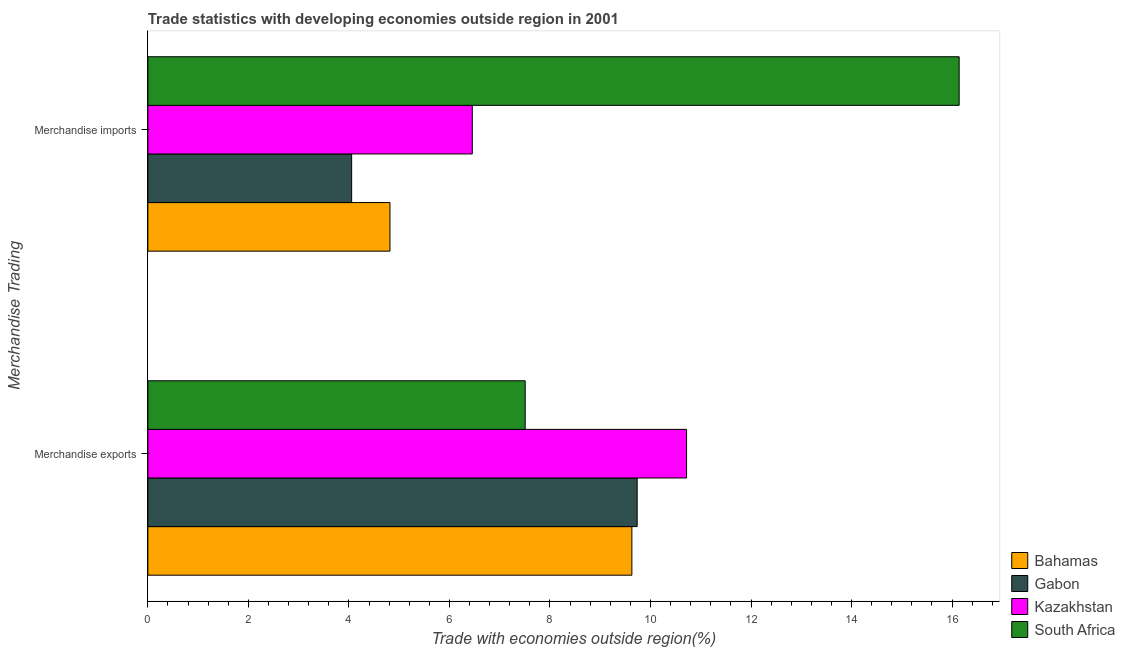How many different coloured bars are there?
Give a very brief answer. 4. How many groups of bars are there?
Ensure brevity in your answer.  2. How many bars are there on the 2nd tick from the top?
Ensure brevity in your answer.  4. What is the label of the 2nd group of bars from the top?
Provide a short and direct response. Merchandise exports. What is the merchandise exports in South Africa?
Make the answer very short. 7.51. Across all countries, what is the maximum merchandise imports?
Give a very brief answer. 16.14. Across all countries, what is the minimum merchandise imports?
Keep it short and to the point. 4.05. In which country was the merchandise exports maximum?
Ensure brevity in your answer.  Kazakhstan. In which country was the merchandise imports minimum?
Your answer should be compact. Gabon. What is the total merchandise imports in the graph?
Your answer should be very brief. 31.47. What is the difference between the merchandise exports in Bahamas and that in South Africa?
Your response must be concise. 2.12. What is the difference between the merchandise imports in Kazakhstan and the merchandise exports in South Africa?
Offer a very short reply. -1.05. What is the average merchandise exports per country?
Provide a short and direct response. 9.4. What is the difference between the merchandise imports and merchandise exports in Kazakhstan?
Your response must be concise. -4.26. In how many countries, is the merchandise imports greater than 4.8 %?
Make the answer very short. 3. What is the ratio of the merchandise imports in Gabon to that in Kazakhstan?
Your response must be concise. 0.63. Is the merchandise exports in Bahamas less than that in Kazakhstan?
Your answer should be very brief. Yes. In how many countries, is the merchandise imports greater than the average merchandise imports taken over all countries?
Your answer should be very brief. 1. What does the 2nd bar from the top in Merchandise imports represents?
Your response must be concise. Kazakhstan. What does the 3rd bar from the bottom in Merchandise exports represents?
Your answer should be very brief. Kazakhstan. How many countries are there in the graph?
Provide a succinct answer. 4. Where does the legend appear in the graph?
Keep it short and to the point. Bottom right. How many legend labels are there?
Your response must be concise. 4. How are the legend labels stacked?
Your answer should be very brief. Vertical. What is the title of the graph?
Offer a terse response. Trade statistics with developing economies outside region in 2001. What is the label or title of the X-axis?
Give a very brief answer. Trade with economies outside region(%). What is the label or title of the Y-axis?
Your response must be concise. Merchandise Trading. What is the Trade with economies outside region(%) of Bahamas in Merchandise exports?
Your answer should be very brief. 9.63. What is the Trade with economies outside region(%) of Gabon in Merchandise exports?
Your answer should be very brief. 9.74. What is the Trade with economies outside region(%) in Kazakhstan in Merchandise exports?
Ensure brevity in your answer.  10.72. What is the Trade with economies outside region(%) in South Africa in Merchandise exports?
Provide a succinct answer. 7.51. What is the Trade with economies outside region(%) of Bahamas in Merchandise imports?
Offer a terse response. 4.82. What is the Trade with economies outside region(%) of Gabon in Merchandise imports?
Your response must be concise. 4.05. What is the Trade with economies outside region(%) in Kazakhstan in Merchandise imports?
Your response must be concise. 6.45. What is the Trade with economies outside region(%) in South Africa in Merchandise imports?
Keep it short and to the point. 16.14. Across all Merchandise Trading, what is the maximum Trade with economies outside region(%) of Bahamas?
Offer a very short reply. 9.63. Across all Merchandise Trading, what is the maximum Trade with economies outside region(%) in Gabon?
Your answer should be compact. 9.74. Across all Merchandise Trading, what is the maximum Trade with economies outside region(%) in Kazakhstan?
Your response must be concise. 10.72. Across all Merchandise Trading, what is the maximum Trade with economies outside region(%) in South Africa?
Make the answer very short. 16.14. Across all Merchandise Trading, what is the minimum Trade with economies outside region(%) in Bahamas?
Provide a short and direct response. 4.82. Across all Merchandise Trading, what is the minimum Trade with economies outside region(%) in Gabon?
Offer a terse response. 4.05. Across all Merchandise Trading, what is the minimum Trade with economies outside region(%) of Kazakhstan?
Your answer should be compact. 6.45. Across all Merchandise Trading, what is the minimum Trade with economies outside region(%) of South Africa?
Offer a terse response. 7.51. What is the total Trade with economies outside region(%) of Bahamas in the graph?
Provide a succinct answer. 14.45. What is the total Trade with economies outside region(%) of Gabon in the graph?
Your answer should be very brief. 13.79. What is the total Trade with economies outside region(%) in Kazakhstan in the graph?
Your response must be concise. 17.17. What is the total Trade with economies outside region(%) of South Africa in the graph?
Offer a terse response. 23.65. What is the difference between the Trade with economies outside region(%) of Bahamas in Merchandise exports and that in Merchandise imports?
Provide a succinct answer. 4.81. What is the difference between the Trade with economies outside region(%) in Gabon in Merchandise exports and that in Merchandise imports?
Ensure brevity in your answer.  5.68. What is the difference between the Trade with economies outside region(%) of Kazakhstan in Merchandise exports and that in Merchandise imports?
Your answer should be very brief. 4.26. What is the difference between the Trade with economies outside region(%) of South Africa in Merchandise exports and that in Merchandise imports?
Make the answer very short. -8.63. What is the difference between the Trade with economies outside region(%) of Bahamas in Merchandise exports and the Trade with economies outside region(%) of Gabon in Merchandise imports?
Your answer should be compact. 5.58. What is the difference between the Trade with economies outside region(%) of Bahamas in Merchandise exports and the Trade with economies outside region(%) of Kazakhstan in Merchandise imports?
Keep it short and to the point. 3.17. What is the difference between the Trade with economies outside region(%) of Bahamas in Merchandise exports and the Trade with economies outside region(%) of South Africa in Merchandise imports?
Offer a very short reply. -6.51. What is the difference between the Trade with economies outside region(%) in Gabon in Merchandise exports and the Trade with economies outside region(%) in Kazakhstan in Merchandise imports?
Provide a short and direct response. 3.28. What is the difference between the Trade with economies outside region(%) of Gabon in Merchandise exports and the Trade with economies outside region(%) of South Africa in Merchandise imports?
Ensure brevity in your answer.  -6.41. What is the difference between the Trade with economies outside region(%) of Kazakhstan in Merchandise exports and the Trade with economies outside region(%) of South Africa in Merchandise imports?
Keep it short and to the point. -5.42. What is the average Trade with economies outside region(%) of Bahamas per Merchandise Trading?
Your answer should be compact. 7.22. What is the average Trade with economies outside region(%) in Gabon per Merchandise Trading?
Offer a very short reply. 6.89. What is the average Trade with economies outside region(%) of Kazakhstan per Merchandise Trading?
Give a very brief answer. 8.59. What is the average Trade with economies outside region(%) in South Africa per Merchandise Trading?
Your answer should be very brief. 11.82. What is the difference between the Trade with economies outside region(%) of Bahamas and Trade with economies outside region(%) of Gabon in Merchandise exports?
Provide a short and direct response. -0.11. What is the difference between the Trade with economies outside region(%) of Bahamas and Trade with economies outside region(%) of Kazakhstan in Merchandise exports?
Provide a short and direct response. -1.09. What is the difference between the Trade with economies outside region(%) of Bahamas and Trade with economies outside region(%) of South Africa in Merchandise exports?
Your answer should be very brief. 2.12. What is the difference between the Trade with economies outside region(%) in Gabon and Trade with economies outside region(%) in Kazakhstan in Merchandise exports?
Your answer should be very brief. -0.98. What is the difference between the Trade with economies outside region(%) in Gabon and Trade with economies outside region(%) in South Africa in Merchandise exports?
Keep it short and to the point. 2.23. What is the difference between the Trade with economies outside region(%) of Kazakhstan and Trade with economies outside region(%) of South Africa in Merchandise exports?
Your response must be concise. 3.21. What is the difference between the Trade with economies outside region(%) of Bahamas and Trade with economies outside region(%) of Gabon in Merchandise imports?
Offer a very short reply. 0.76. What is the difference between the Trade with economies outside region(%) in Bahamas and Trade with economies outside region(%) in Kazakhstan in Merchandise imports?
Your answer should be compact. -1.64. What is the difference between the Trade with economies outside region(%) of Bahamas and Trade with economies outside region(%) of South Africa in Merchandise imports?
Provide a short and direct response. -11.32. What is the difference between the Trade with economies outside region(%) in Gabon and Trade with economies outside region(%) in Kazakhstan in Merchandise imports?
Give a very brief answer. -2.4. What is the difference between the Trade with economies outside region(%) of Gabon and Trade with economies outside region(%) of South Africa in Merchandise imports?
Your answer should be compact. -12.09. What is the difference between the Trade with economies outside region(%) in Kazakhstan and Trade with economies outside region(%) in South Africa in Merchandise imports?
Your answer should be compact. -9.69. What is the ratio of the Trade with economies outside region(%) of Bahamas in Merchandise exports to that in Merchandise imports?
Keep it short and to the point. 2. What is the ratio of the Trade with economies outside region(%) of Gabon in Merchandise exports to that in Merchandise imports?
Offer a terse response. 2.4. What is the ratio of the Trade with economies outside region(%) of Kazakhstan in Merchandise exports to that in Merchandise imports?
Your response must be concise. 1.66. What is the ratio of the Trade with economies outside region(%) in South Africa in Merchandise exports to that in Merchandise imports?
Keep it short and to the point. 0.47. What is the difference between the highest and the second highest Trade with economies outside region(%) in Bahamas?
Offer a very short reply. 4.81. What is the difference between the highest and the second highest Trade with economies outside region(%) in Gabon?
Your answer should be compact. 5.68. What is the difference between the highest and the second highest Trade with economies outside region(%) in Kazakhstan?
Keep it short and to the point. 4.26. What is the difference between the highest and the second highest Trade with economies outside region(%) in South Africa?
Give a very brief answer. 8.63. What is the difference between the highest and the lowest Trade with economies outside region(%) of Bahamas?
Ensure brevity in your answer.  4.81. What is the difference between the highest and the lowest Trade with economies outside region(%) in Gabon?
Offer a terse response. 5.68. What is the difference between the highest and the lowest Trade with economies outside region(%) of Kazakhstan?
Offer a terse response. 4.26. What is the difference between the highest and the lowest Trade with economies outside region(%) in South Africa?
Your response must be concise. 8.63. 